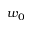<formula> <loc_0><loc_0><loc_500><loc_500>w _ { 0 }</formula> 